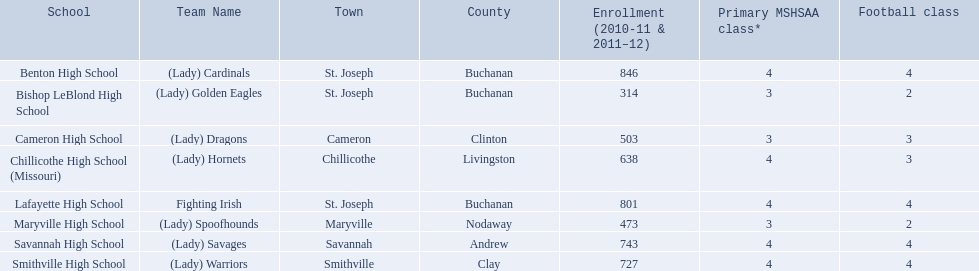What are the three learning establishments in st. joseph's town? St. Joseph, St. Joseph, St. Joseph. Among the three establishments in st. joseph, which school's team name does not portray an animal type? Lafayette High School. Which team is identified by the colors green and grey? Fighting Irish. What are they called? Lafayette High School. Help me parse the entirety of this table. {'header': ['School', 'Team Name', 'Town', 'County', 'Enrollment (2010-11 & 2011–12)', 'Primary MSHSAA class*', 'Football class'], 'rows': [['Benton High School', '(Lady) Cardinals', 'St. Joseph', 'Buchanan', '846', '4', '4'], ['Bishop LeBlond High School', '(Lady) Golden Eagles', 'St. Joseph', 'Buchanan', '314', '3', '2'], ['Cameron High School', '(Lady) Dragons', 'Cameron', 'Clinton', '503', '3', '3'], ['Chillicothe High School (Missouri)', '(Lady) Hornets', 'Chillicothe', 'Livingston', '638', '4', '3'], ['Lafayette High School', 'Fighting Irish', 'St. Joseph', 'Buchanan', '801', '4', '4'], ['Maryville High School', '(Lady) Spoofhounds', 'Maryville', 'Nodaway', '473', '3', '2'], ['Savannah High School', '(Lady) Savages', 'Savannah', 'Andrew', '743', '4', '4'], ['Smithville High School', '(Lady) Warriors', 'Smithville', 'Clay', '727', '4', '4']]} 